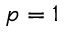<formula> <loc_0><loc_0><loc_500><loc_500>p = 1</formula> 